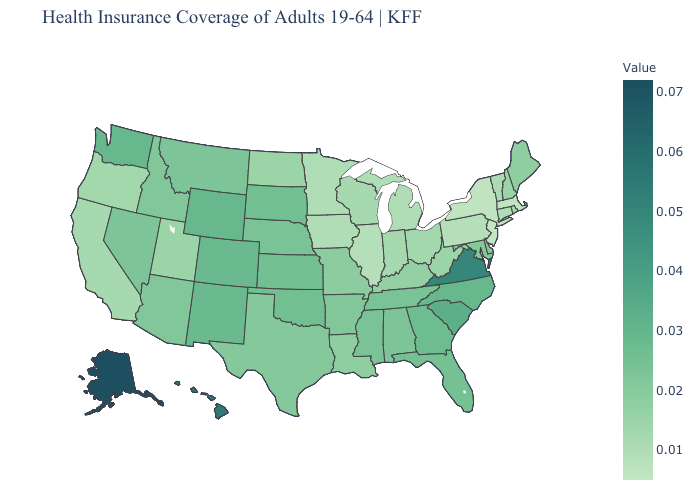Among the states that border Montana , does North Dakota have the lowest value?
Write a very short answer. Yes. Among the states that border Indiana , does Kentucky have the highest value?
Keep it brief. Yes. Is the legend a continuous bar?
Concise answer only. Yes. Does Maine have the highest value in the Northeast?
Answer briefly. Yes. Does Rhode Island have the lowest value in the Northeast?
Give a very brief answer. No. Does Alaska have the highest value in the USA?
Concise answer only. Yes. Does Iowa have a lower value than Louisiana?
Quick response, please. Yes. 